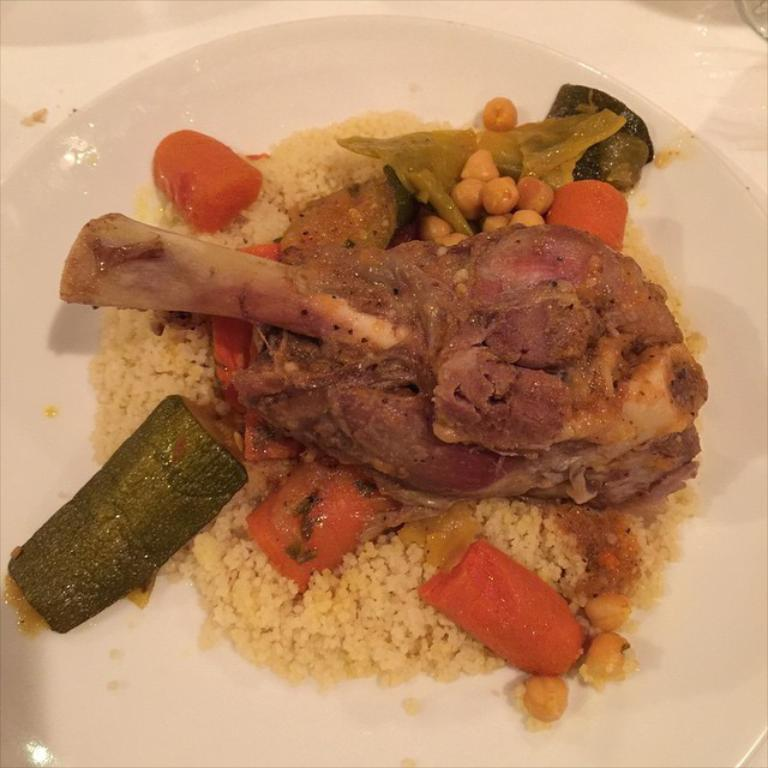What is on the plate that is visible in the image? There is a food item on a plate in the image. Where is the plate located in the image? The plate is placed on a table in the image. What reward does the fireman receive for saving the day in the image? There is no fireman or reward present in the image; it only features a plate with a food item on it. 